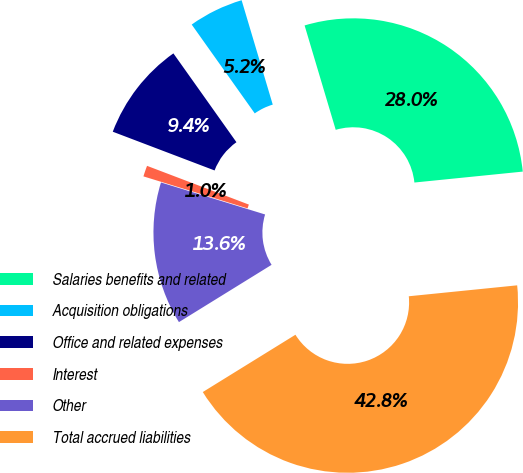Convert chart. <chart><loc_0><loc_0><loc_500><loc_500><pie_chart><fcel>Salaries benefits and related<fcel>Acquisition obligations<fcel>Office and related expenses<fcel>Interest<fcel>Other<fcel>Total accrued liabilities<nl><fcel>28.01%<fcel>5.21%<fcel>9.39%<fcel>1.04%<fcel>13.56%<fcel>42.78%<nl></chart> 